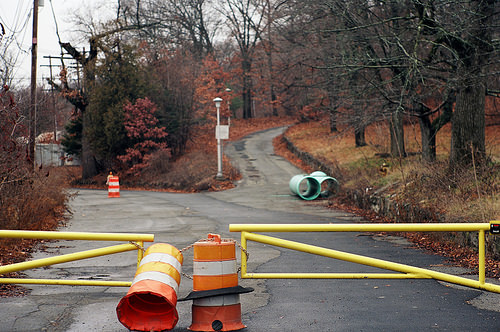<image>
Is the traffic cone in front of the tree? Yes. The traffic cone is positioned in front of the tree, appearing closer to the camera viewpoint. 